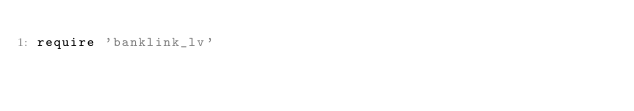<code> <loc_0><loc_0><loc_500><loc_500><_Ruby_>require 'banklink_lv'</code> 